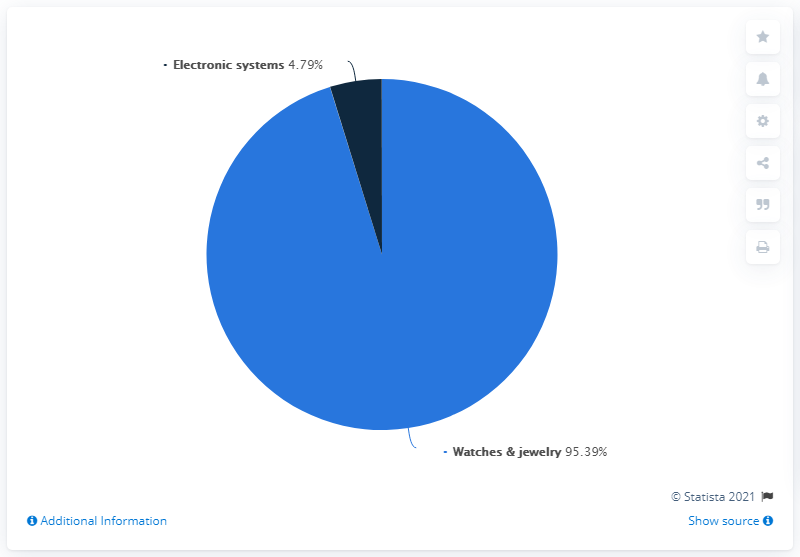Outline some significant characteristics in this image. In 2020, the watches and jewelry segment generated a revenue share of 95.39%. What is the difference between two products in terms of contributing to revenue? The former has contributed 90.6% to the total revenue. Watches and jewelry are products that generate the most revenue. 